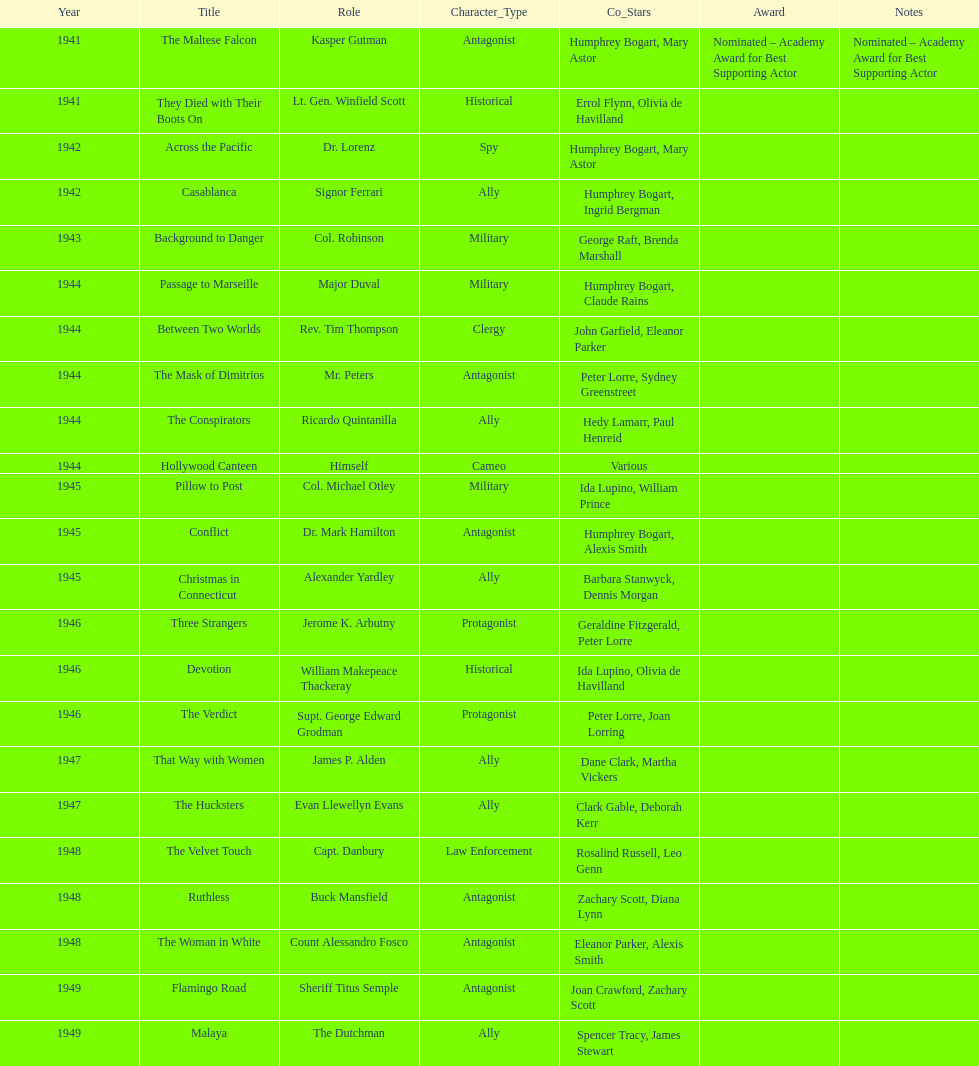What movies did greenstreet act for in 1946? Three Strangers, Devotion, The Verdict. 